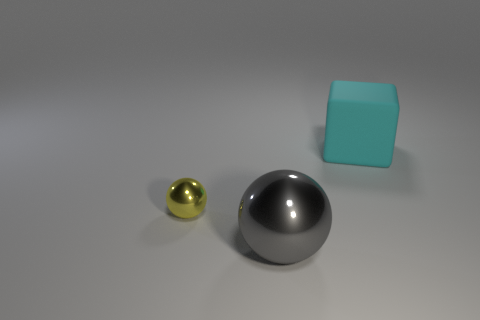Add 3 gray things. How many objects exist? 6 Subtract all cubes. How many objects are left? 2 Add 2 matte cubes. How many matte cubes are left? 3 Add 2 small yellow rubber cubes. How many small yellow rubber cubes exist? 2 Subtract 0 blue blocks. How many objects are left? 3 Subtract all gray shiny spheres. Subtract all tiny yellow metallic objects. How many objects are left? 1 